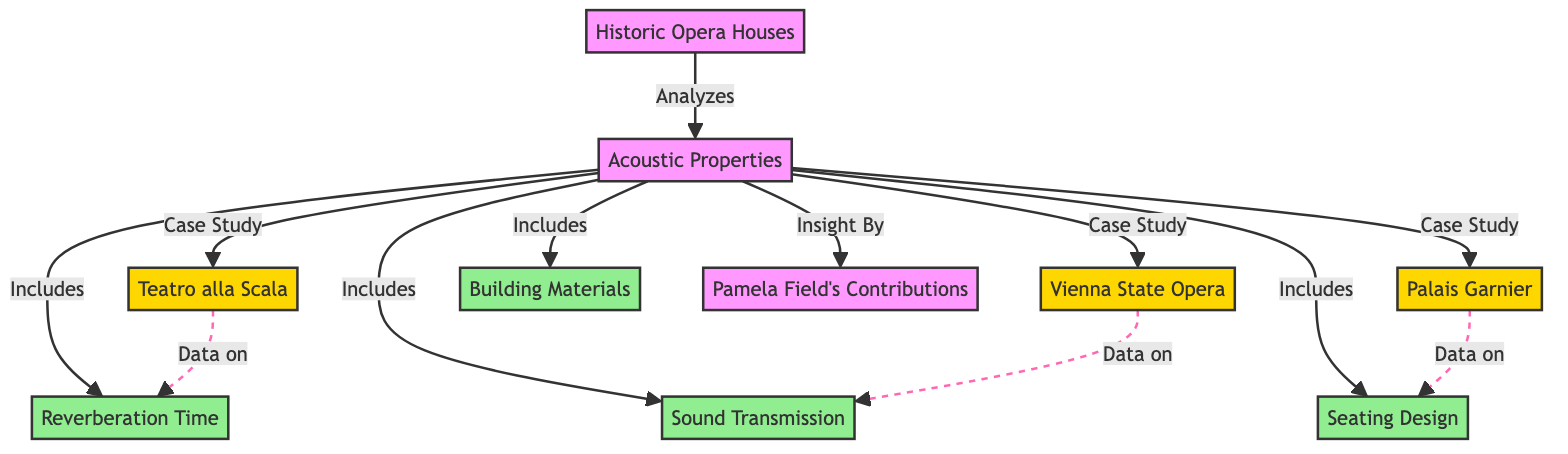What are the three historic opera houses mentioned in the diagram? The diagram lists Teatro alla Scala, Vienna State Opera, and Palais Garnier as the historic opera houses analyzed for their acoustic properties.
Answer: Teatro alla Scala, Vienna State Opera, Palais Garnier What acoustic property is associated with Teatro alla Scala? The diagram indicates that Teatro alla Scala is linked to the acoustic property of Reverberation Time.
Answer: Reverberation Time How many acoustic properties are included in the analysis? The diagram lists four specific acoustic properties: Reverberation Time, Sound Transmission, Seating Design, and Building Materials.
Answer: Four Which opera house includes data on Sound Transmission? According to the diagram, the Vienna State Opera is the opera house that includes data on Sound Transmission.
Answer: Vienna State Opera What relationship does Pamela Field have in the context of the acoustic properties? The diagram shows that Pamela Field provides an insight related to the acoustic properties of historic opera houses.
Answer: Insight By Explain the flow of information from the "Historic Opera Houses" node to "Acoustic Properties." The diagram starts with the "Historic Opera Houses" node, which is analyzed to understand their "Acoustic Properties." This connection implies that the study examines how these opera houses influence or relate to the described acoustic properties.
Answer: Analyzes How many nodes represent specific acoustic properties in the diagram? Four nodes specifically represent the acoustic properties: Reverberation Time, Sound Transmission, Seating Design, and Building Materials.
Answer: Four What is the linking relationship between Palais Garnier and its specific acoustic property? The diagram shows a dashed line indicating the relationship between Palais Garnier and Seating Design, suggesting that this opera house contains relevant data in this area.
Answer: Data on Seating Design 